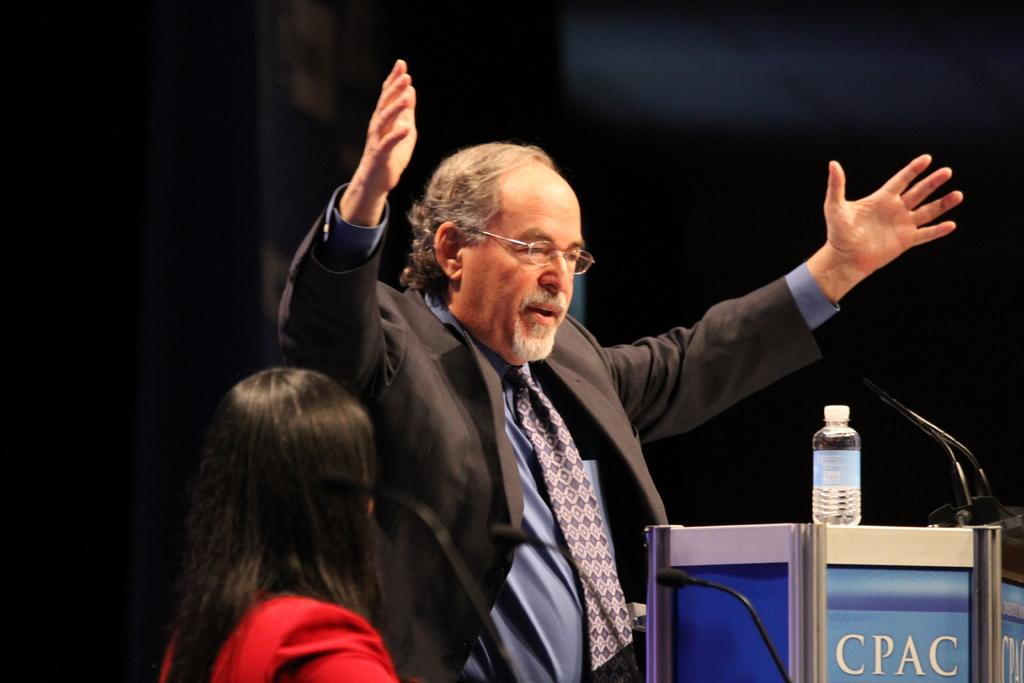<image>
Present a compact description of the photo's key features. A male stands giving a lecture at a CPAC conference. 